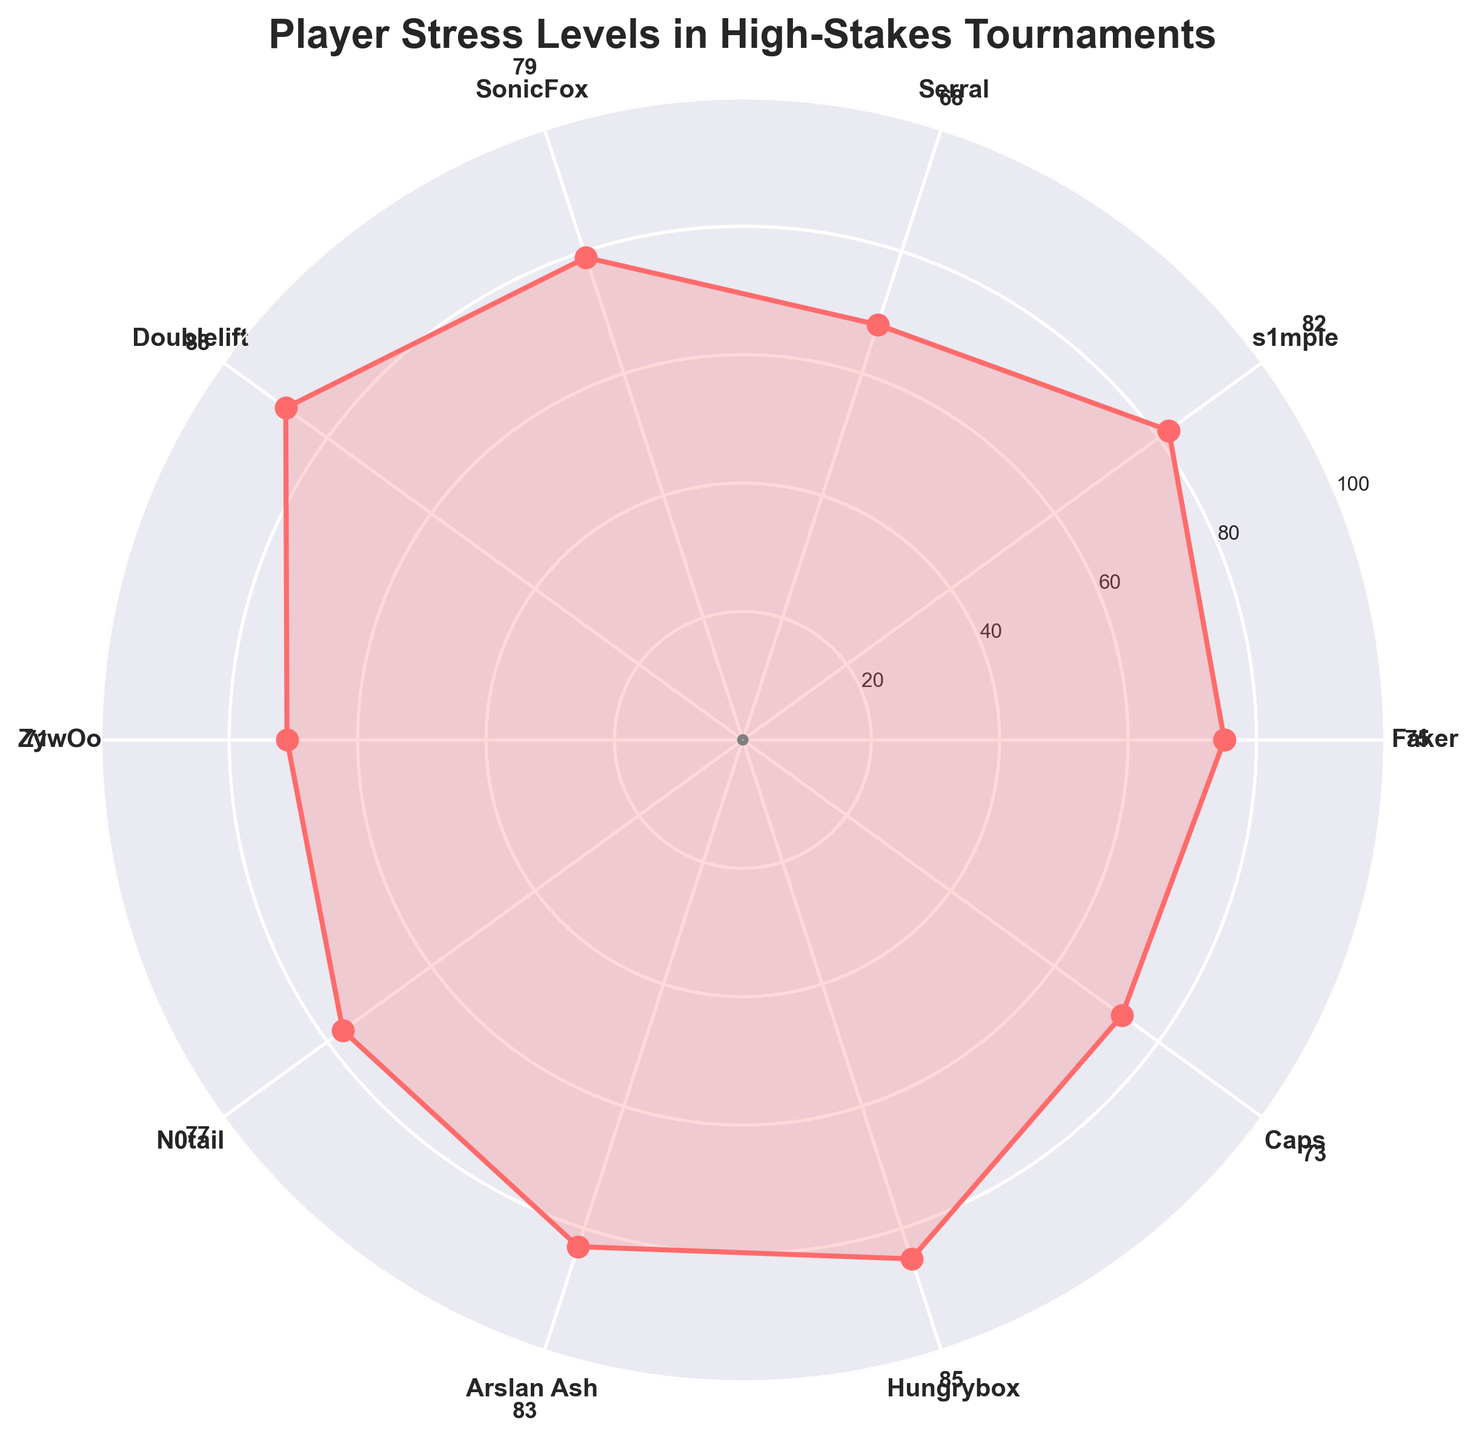Who has the highest stress level in the tournament? To find the player with the highest stress level, look for the highest value on the gauge chart. Doublelift has the highest stress level at 88.
Answer: Doublelift What is the average stress level of all players? Add up all the stress levels (75 + 82 + 68 + 79 + 88 + 71 + 77 + 83 + 85 + 73) to get the total, which is 781. Divide this by the number of players (10). The average stress level is 78.1.
Answer: 78.1 Which player has a stress level less than 70? Look for players whose stress levels are below 70 on the gauge chart. Serral has a stress level of 68.
Answer: Serral Compare the stress levels of N0tail and Hungrybox. Which one has a lower stress level? N0tail has a stress level of 77, while Hungrybox has a stress level of 85. Therefore, N0tail has a lower stress level.
Answer: N0tail What is the sum of the stress levels of Faker, Serral, and ZywOo? Add up the stress levels of Faker (75), Serral (68), and ZywOo (71). The sum is 75 + 68 + 71 = 214.
Answer: 214 What is the difference in stress levels between Caps and SonicFox? Subtract the stress level of Caps (73) from that of SonicFox (79). The difference is 79 - 73 = 6.
Answer: 6 How many players have stress levels above 80? Count the number of players with stress levels above 80. The players are s1mple (82), Doublelift (88), Arslan Ash (83), and Hungrybox (85), making a total of 4 players.
Answer: 4 What is the range of stress levels among the players? Find the difference between the highest and lowest stress levels. The highest is 88 (Doublelift) and the lowest is 68 (Serral). The range is 88 - 68 = 20.
Answer: 20 Identify the players with stress levels between 70 and 80 inclusive? List the players whose stress levels fall within the range of 70 to 80. The players are Faker (75), SonicFox (79), ZywOo (71), and N0tail (77).
Answer: Faker, SonicFox, ZywOo, N0tail 